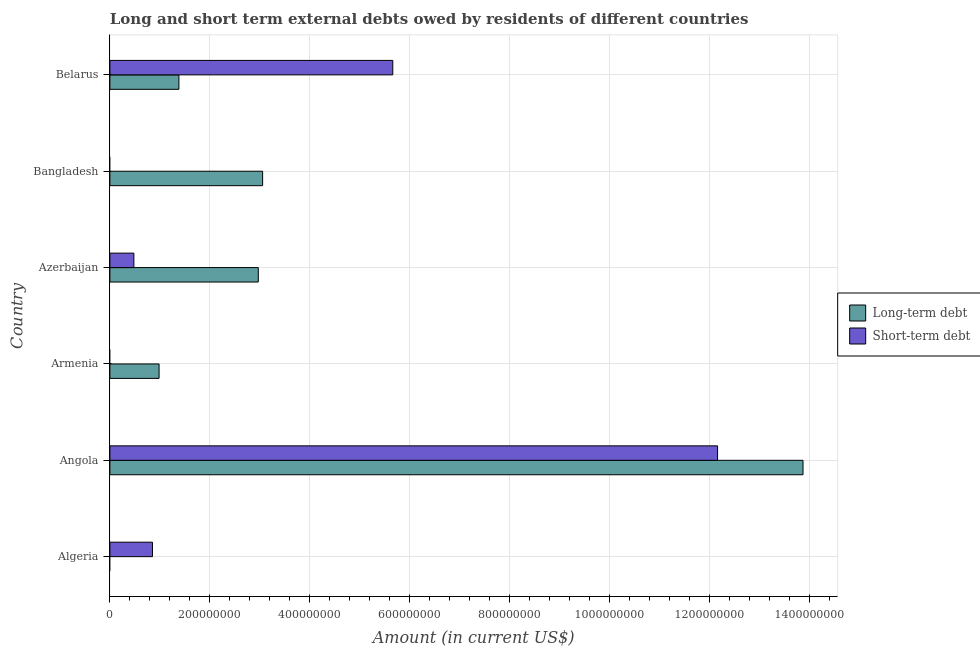How many different coloured bars are there?
Provide a short and direct response. 2. Are the number of bars on each tick of the Y-axis equal?
Make the answer very short. No. How many bars are there on the 1st tick from the bottom?
Offer a very short reply. 1. What is the label of the 1st group of bars from the top?
Your answer should be compact. Belarus. In how many cases, is the number of bars for a given country not equal to the number of legend labels?
Make the answer very short. 3. What is the long-term debts owed by residents in Armenia?
Make the answer very short. 9.84e+07. Across all countries, what is the maximum long-term debts owed by residents?
Keep it short and to the point. 1.39e+09. In which country was the long-term debts owed by residents maximum?
Keep it short and to the point. Angola. What is the total short-term debts owed by residents in the graph?
Your answer should be compact. 1.92e+09. What is the difference between the short-term debts owed by residents in Angola and that in Azerbaijan?
Ensure brevity in your answer.  1.17e+09. What is the difference between the short-term debts owed by residents in Bangladesh and the long-term debts owed by residents in Belarus?
Offer a very short reply. -1.38e+08. What is the average long-term debts owed by residents per country?
Your answer should be compact. 3.71e+08. What is the difference between the short-term debts owed by residents and long-term debts owed by residents in Belarus?
Give a very brief answer. 4.28e+08. What is the ratio of the short-term debts owed by residents in Algeria to that in Azerbaijan?
Provide a succinct answer. 1.77. What is the difference between the highest and the second highest long-term debts owed by residents?
Provide a succinct answer. 1.08e+09. What is the difference between the highest and the lowest short-term debts owed by residents?
Offer a very short reply. 1.22e+09. Is the sum of the long-term debts owed by residents in Bangladesh and Belarus greater than the maximum short-term debts owed by residents across all countries?
Provide a short and direct response. No. Are all the bars in the graph horizontal?
Make the answer very short. Yes. How many countries are there in the graph?
Keep it short and to the point. 6. Does the graph contain any zero values?
Give a very brief answer. Yes. Does the graph contain grids?
Your answer should be compact. Yes. How many legend labels are there?
Offer a very short reply. 2. What is the title of the graph?
Ensure brevity in your answer.  Long and short term external debts owed by residents of different countries. Does "By country of asylum" appear as one of the legend labels in the graph?
Offer a very short reply. No. What is the label or title of the X-axis?
Your answer should be compact. Amount (in current US$). What is the Amount (in current US$) of Short-term debt in Algeria?
Keep it short and to the point. 8.52e+07. What is the Amount (in current US$) of Long-term debt in Angola?
Make the answer very short. 1.39e+09. What is the Amount (in current US$) in Short-term debt in Angola?
Give a very brief answer. 1.22e+09. What is the Amount (in current US$) of Long-term debt in Armenia?
Ensure brevity in your answer.  9.84e+07. What is the Amount (in current US$) of Long-term debt in Azerbaijan?
Your answer should be compact. 2.97e+08. What is the Amount (in current US$) of Short-term debt in Azerbaijan?
Your answer should be compact. 4.80e+07. What is the Amount (in current US$) of Long-term debt in Bangladesh?
Provide a succinct answer. 3.06e+08. What is the Amount (in current US$) of Long-term debt in Belarus?
Provide a succinct answer. 1.38e+08. What is the Amount (in current US$) in Short-term debt in Belarus?
Offer a terse response. 5.66e+08. Across all countries, what is the maximum Amount (in current US$) of Long-term debt?
Offer a terse response. 1.39e+09. Across all countries, what is the maximum Amount (in current US$) of Short-term debt?
Keep it short and to the point. 1.22e+09. Across all countries, what is the minimum Amount (in current US$) in Long-term debt?
Make the answer very short. 0. Across all countries, what is the minimum Amount (in current US$) of Short-term debt?
Offer a very short reply. 0. What is the total Amount (in current US$) of Long-term debt in the graph?
Make the answer very short. 2.23e+09. What is the total Amount (in current US$) in Short-term debt in the graph?
Your response must be concise. 1.92e+09. What is the difference between the Amount (in current US$) of Short-term debt in Algeria and that in Angola?
Give a very brief answer. -1.13e+09. What is the difference between the Amount (in current US$) in Short-term debt in Algeria and that in Azerbaijan?
Make the answer very short. 3.72e+07. What is the difference between the Amount (in current US$) in Short-term debt in Algeria and that in Belarus?
Give a very brief answer. -4.81e+08. What is the difference between the Amount (in current US$) in Long-term debt in Angola and that in Armenia?
Give a very brief answer. 1.29e+09. What is the difference between the Amount (in current US$) of Long-term debt in Angola and that in Azerbaijan?
Offer a very short reply. 1.09e+09. What is the difference between the Amount (in current US$) of Short-term debt in Angola and that in Azerbaijan?
Give a very brief answer. 1.17e+09. What is the difference between the Amount (in current US$) of Long-term debt in Angola and that in Bangladesh?
Give a very brief answer. 1.08e+09. What is the difference between the Amount (in current US$) of Long-term debt in Angola and that in Belarus?
Your response must be concise. 1.25e+09. What is the difference between the Amount (in current US$) in Short-term debt in Angola and that in Belarus?
Your answer should be very brief. 6.50e+08. What is the difference between the Amount (in current US$) in Long-term debt in Armenia and that in Azerbaijan?
Give a very brief answer. -1.99e+08. What is the difference between the Amount (in current US$) in Long-term debt in Armenia and that in Bangladesh?
Make the answer very short. -2.07e+08. What is the difference between the Amount (in current US$) of Long-term debt in Armenia and that in Belarus?
Give a very brief answer. -3.97e+07. What is the difference between the Amount (in current US$) of Long-term debt in Azerbaijan and that in Bangladesh?
Make the answer very short. -8.67e+06. What is the difference between the Amount (in current US$) of Long-term debt in Azerbaijan and that in Belarus?
Your response must be concise. 1.59e+08. What is the difference between the Amount (in current US$) in Short-term debt in Azerbaijan and that in Belarus?
Your response must be concise. -5.18e+08. What is the difference between the Amount (in current US$) of Long-term debt in Bangladesh and that in Belarus?
Provide a short and direct response. 1.67e+08. What is the difference between the Amount (in current US$) of Long-term debt in Angola and the Amount (in current US$) of Short-term debt in Azerbaijan?
Provide a succinct answer. 1.34e+09. What is the difference between the Amount (in current US$) in Long-term debt in Angola and the Amount (in current US$) in Short-term debt in Belarus?
Ensure brevity in your answer.  8.21e+08. What is the difference between the Amount (in current US$) in Long-term debt in Armenia and the Amount (in current US$) in Short-term debt in Azerbaijan?
Offer a terse response. 5.04e+07. What is the difference between the Amount (in current US$) of Long-term debt in Armenia and the Amount (in current US$) of Short-term debt in Belarus?
Provide a succinct answer. -4.68e+08. What is the difference between the Amount (in current US$) of Long-term debt in Azerbaijan and the Amount (in current US$) of Short-term debt in Belarus?
Provide a short and direct response. -2.69e+08. What is the difference between the Amount (in current US$) of Long-term debt in Bangladesh and the Amount (in current US$) of Short-term debt in Belarus?
Provide a short and direct response. -2.60e+08. What is the average Amount (in current US$) of Long-term debt per country?
Your answer should be compact. 3.71e+08. What is the average Amount (in current US$) in Short-term debt per country?
Offer a very short reply. 3.19e+08. What is the difference between the Amount (in current US$) in Long-term debt and Amount (in current US$) in Short-term debt in Angola?
Ensure brevity in your answer.  1.71e+08. What is the difference between the Amount (in current US$) in Long-term debt and Amount (in current US$) in Short-term debt in Azerbaijan?
Offer a terse response. 2.49e+08. What is the difference between the Amount (in current US$) of Long-term debt and Amount (in current US$) of Short-term debt in Belarus?
Offer a terse response. -4.28e+08. What is the ratio of the Amount (in current US$) in Short-term debt in Algeria to that in Angola?
Provide a succinct answer. 0.07. What is the ratio of the Amount (in current US$) of Short-term debt in Algeria to that in Azerbaijan?
Give a very brief answer. 1.78. What is the ratio of the Amount (in current US$) of Short-term debt in Algeria to that in Belarus?
Your response must be concise. 0.15. What is the ratio of the Amount (in current US$) of Long-term debt in Angola to that in Armenia?
Your answer should be compact. 14.09. What is the ratio of the Amount (in current US$) in Long-term debt in Angola to that in Azerbaijan?
Provide a short and direct response. 4.67. What is the ratio of the Amount (in current US$) in Short-term debt in Angola to that in Azerbaijan?
Your response must be concise. 25.33. What is the ratio of the Amount (in current US$) in Long-term debt in Angola to that in Bangladesh?
Provide a short and direct response. 4.54. What is the ratio of the Amount (in current US$) of Long-term debt in Angola to that in Belarus?
Make the answer very short. 10.04. What is the ratio of the Amount (in current US$) of Short-term debt in Angola to that in Belarus?
Keep it short and to the point. 2.15. What is the ratio of the Amount (in current US$) in Long-term debt in Armenia to that in Azerbaijan?
Ensure brevity in your answer.  0.33. What is the ratio of the Amount (in current US$) of Long-term debt in Armenia to that in Bangladesh?
Provide a short and direct response. 0.32. What is the ratio of the Amount (in current US$) of Long-term debt in Armenia to that in Belarus?
Offer a very short reply. 0.71. What is the ratio of the Amount (in current US$) of Long-term debt in Azerbaijan to that in Bangladesh?
Offer a terse response. 0.97. What is the ratio of the Amount (in current US$) in Long-term debt in Azerbaijan to that in Belarus?
Make the answer very short. 2.15. What is the ratio of the Amount (in current US$) in Short-term debt in Azerbaijan to that in Belarus?
Your response must be concise. 0.08. What is the ratio of the Amount (in current US$) of Long-term debt in Bangladesh to that in Belarus?
Keep it short and to the point. 2.21. What is the difference between the highest and the second highest Amount (in current US$) of Long-term debt?
Provide a succinct answer. 1.08e+09. What is the difference between the highest and the second highest Amount (in current US$) in Short-term debt?
Ensure brevity in your answer.  6.50e+08. What is the difference between the highest and the lowest Amount (in current US$) of Long-term debt?
Offer a terse response. 1.39e+09. What is the difference between the highest and the lowest Amount (in current US$) in Short-term debt?
Ensure brevity in your answer.  1.22e+09. 